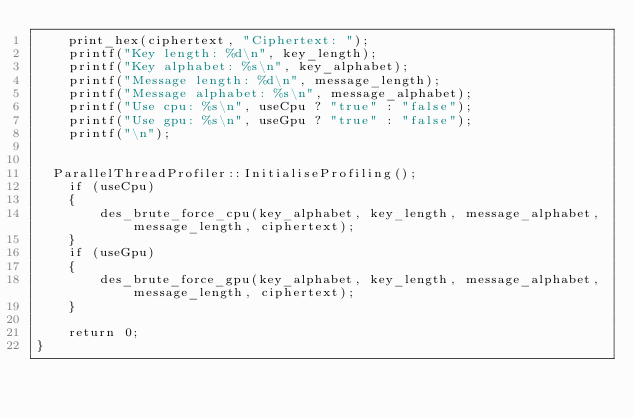Convert code to text. <code><loc_0><loc_0><loc_500><loc_500><_Cuda_>    print_hex(ciphertext, "Ciphertext: ");
    printf("Key length: %d\n", key_length);
    printf("Key alphabet: %s\n", key_alphabet);
    printf("Message length: %d\n", message_length);
    printf("Message alphabet: %s\n", message_alphabet);
    printf("Use cpu: %s\n", useCpu ? "true" : "false");
    printf("Use gpu: %s\n", useGpu ? "true" : "false");
    printf("\n");


	ParallelThreadProfiler::InitialiseProfiling();
    if (useCpu)
    {
        des_brute_force_cpu(key_alphabet, key_length, message_alphabet, message_length, ciphertext);
    }
    if (useGpu)
    {
        des_brute_force_gpu(key_alphabet, key_length, message_alphabet, message_length, ciphertext);
    }

    return 0;
}</code> 